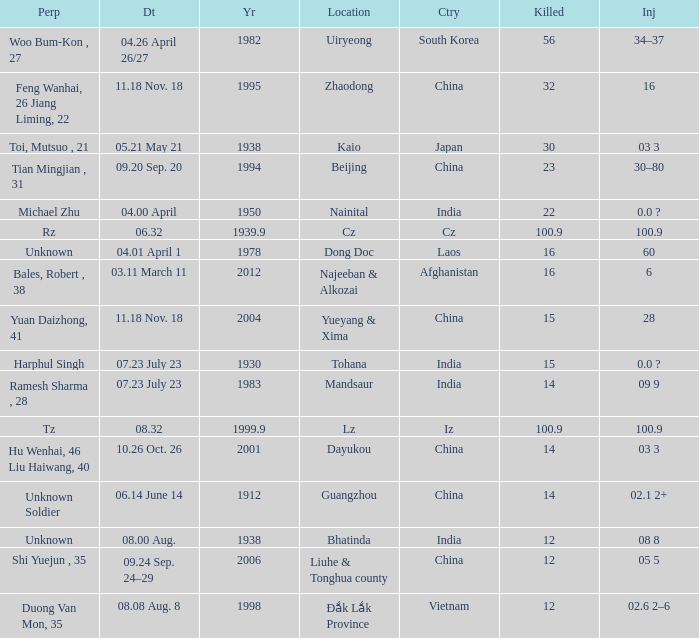9, and when "year" surpasses 193 Iz. 